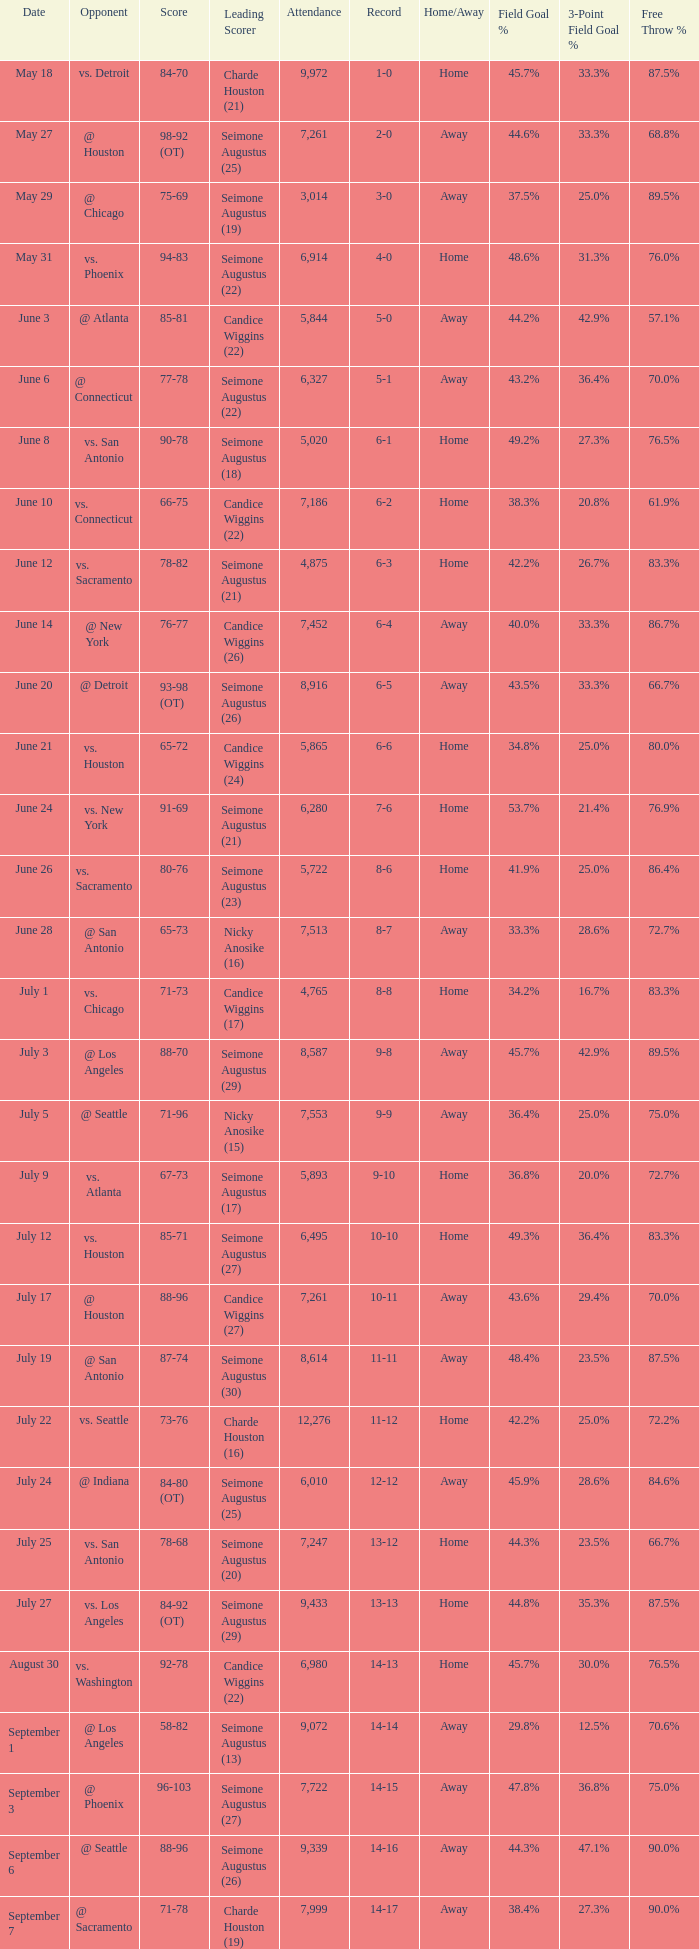Which Score has an Opponent of @ houston, and a Record of 2-0? 98-92 (OT). 